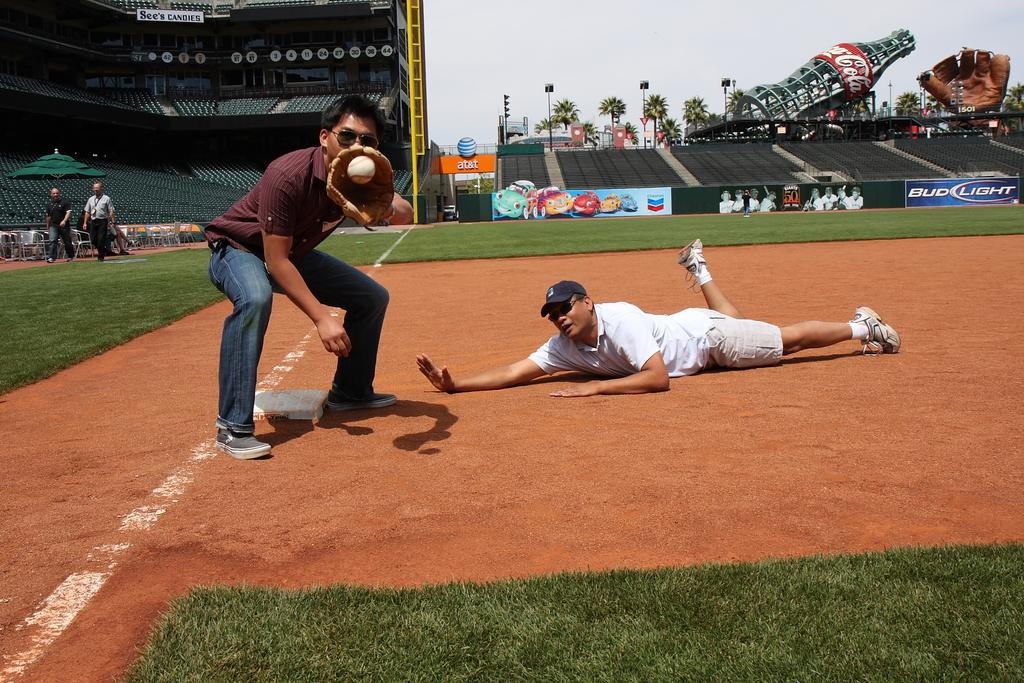What is the man in the image trying to do? The man in the image is trying to catch a ball. What is the position of the other man in the image? The other man is lying on the ground in the image. What type of surface is visible in the image? There is grass in the image. What type of furniture is present in the image? There are chairs in the image. What type of vegetation is visible in the image? There are trees in the image. What object can be seen near the men in the image? There is a bottle in the image. What part of the natural environment is visible in the image? The sky is visible in the image. What type of copper record can be seen in the image? There is no copper record present in the image. What type of cloud is blocking the sun in the image? There is no cloud blocking the sun in the image; the sky is visible. 